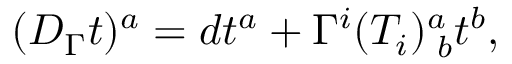Convert formula to latex. <formula><loc_0><loc_0><loc_500><loc_500>( D _ { \Gamma } t ) ^ { a } = d t ^ { a } + \Gamma ^ { i } ( T _ { i } ) _ { \, b } ^ { a } t ^ { b } ,</formula> 